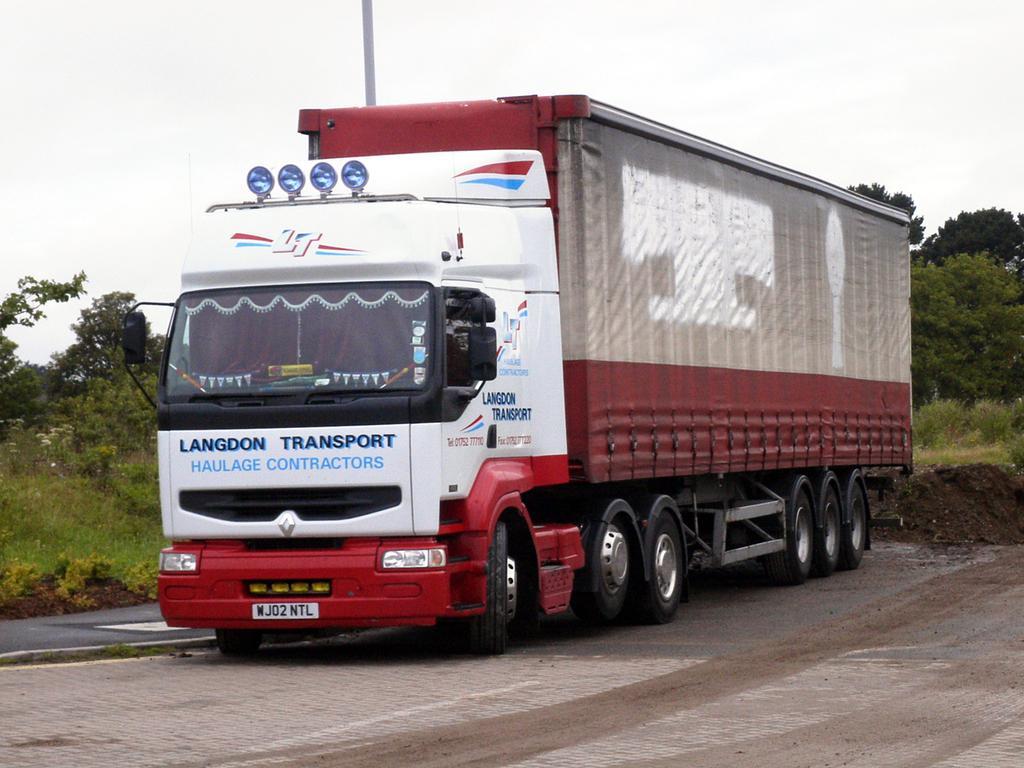Please provide a concise description of this image. In this picture there is a lorry on the road. We can observe white and red color lorry. In the background there are trees and a sky. 